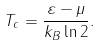<formula> <loc_0><loc_0><loc_500><loc_500>T _ { c } = \frac { \varepsilon - \mu } { k _ { B } \ln { 2 } } \/ .</formula> 